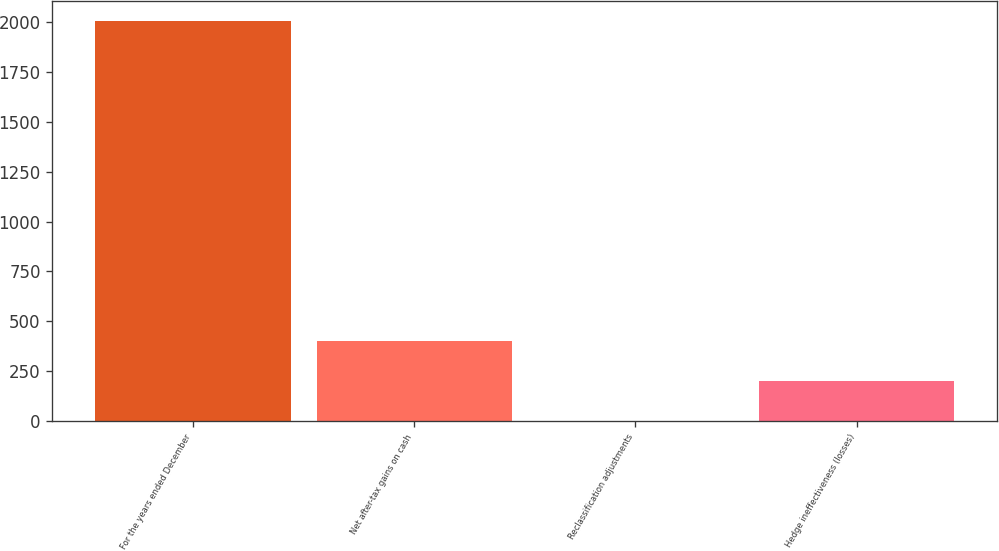Convert chart to OTSL. <chart><loc_0><loc_0><loc_500><loc_500><bar_chart><fcel>For the years ended December<fcel>Net after-tax gains on cash<fcel>Reclassification adjustments<fcel>Hedge ineffectiveness (losses)<nl><fcel>2007<fcel>401.56<fcel>0.2<fcel>200.88<nl></chart> 